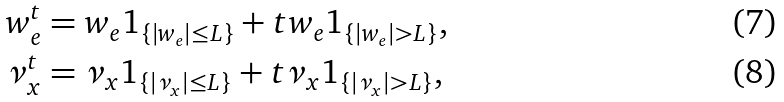Convert formula to latex. <formula><loc_0><loc_0><loc_500><loc_500>w _ { e } ^ { t } & = w _ { e } 1 _ { \{ | w _ { e } | \leq L \} } + t w _ { e } 1 _ { \{ | w _ { e } | > L \} } , \\ \nu _ { x } ^ { t } & = \nu _ { x } 1 _ { \{ | \nu _ { x } | \leq L \} } + t \nu _ { x } 1 _ { \{ | \nu _ { x } | > L \} } ,</formula> 